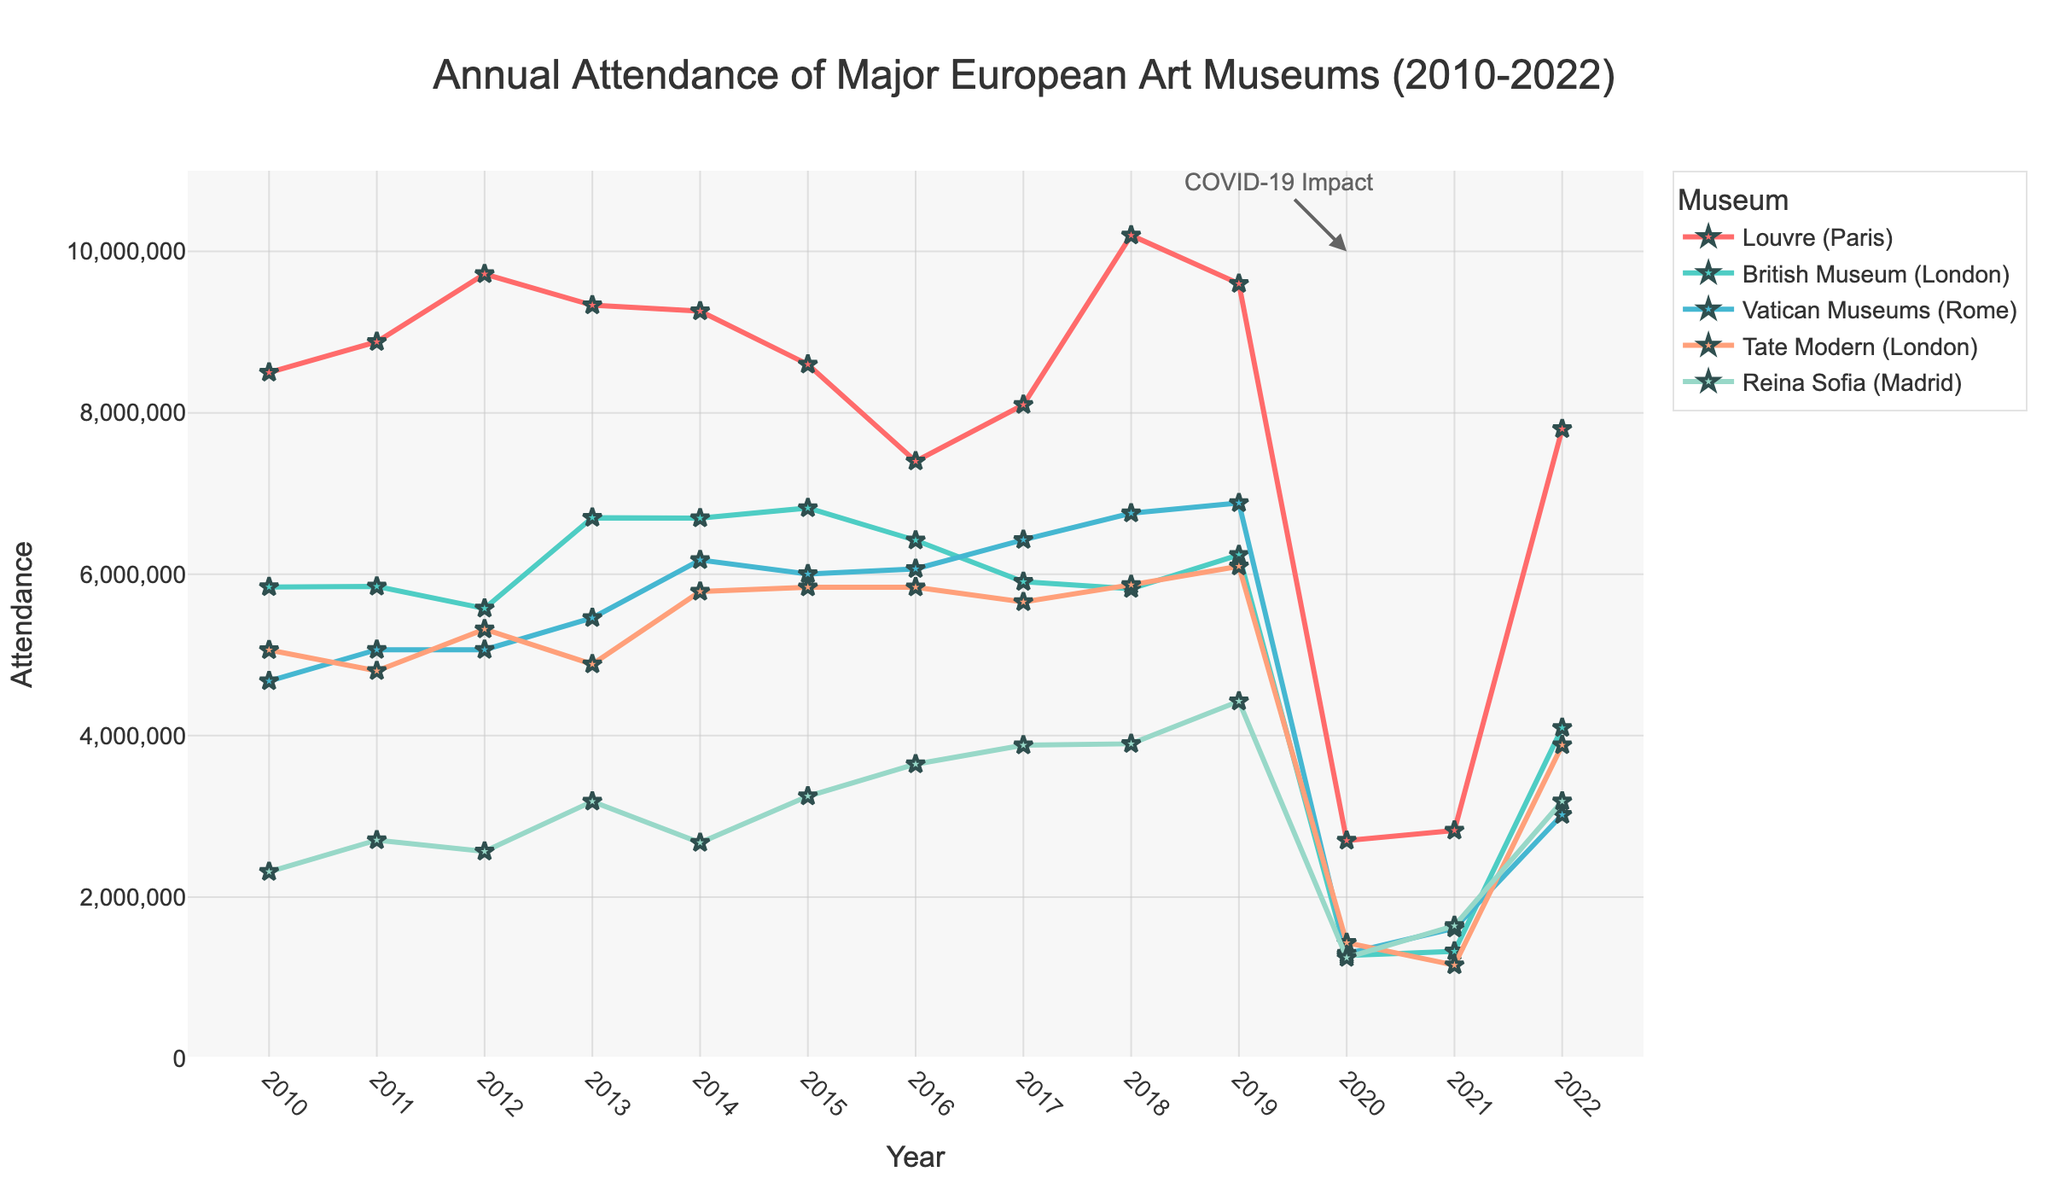Which museum had the highest attendance in 2018? The figure shows the annual attendance for each museum, and in 2018, the Louvre in Paris had the highest attendance compared to the British Museum, Vatican Museums, Tate Modern, and Reina Sofia by having the data point furthest along the vertical axis.
Answer: Louvre How did the attendance at the British Museum change from 2019 to 2022? The data points for the British Museum show a decrease in attendance from 6,239,983 in 2019 to 4,097,253 in 2022, indicating a drop in attendance over this period.
Answer: Decreased Which museum experienced the highest drop in attendance between 2019 and 2020? By observing the vertical distances between the points for 2019 and 2020, the Louvre saw the most significant drop in numbers, decreasing from about 9,600,000 in 2019 to 2,700,000 in 2020.
Answer: Louvre Compare the attendance of Tate Modern and Reina Sofia in 2021. Which museum had higher numbers? In 2021, the figure shows the Tate Modern has an attendance point below Reina Sofia. Therefore, Reina Sofia had higher attendance figures in that year.
Answer: Reina Sofia What is the average attendance for the Vatican Museums from 2010 to 2012? The attendance figures for the Vatican Museums from 2010 to 2012 are 4,676,179, 5,064,546, and 5,064,608, respectively. Summing these up gives 14,805,333, and dividing by 3 (the number of years) gives approximately 4,935,111.
Answer: 4,935,111 Between which consecutive years did the British Museum see the smallest change in attendance? By examining the figure, the smallest change appears between 2010 and 2011, where the numbers are relatively stable with a minimal increase from about 5,842,138 to 5,848,534.
Answer: 2010 to 2011 Which museum had the lowest attendance in 2020? Observing the attendance values for 2020, the Tate Modern had the lowest attendance with about 1,432,991 visitors.
Answer: Tate Modern What were the attendance figures for all museums in 2022? The figure displays that in 2022, the Louvre had an attendance of 7,800,000, the British Museum had 4,097,253, the Vatican Museums had 3,019,275, Tate Modern had 3,883,160, and Reina Sofia had 3,185,665.
Answer: Louvre: 7,800,000, British Museum: 4,097,253, Vatican Museums: 3,019,275, Tate Modern: 3,883,160, Reina Sofia: 3,185,665 